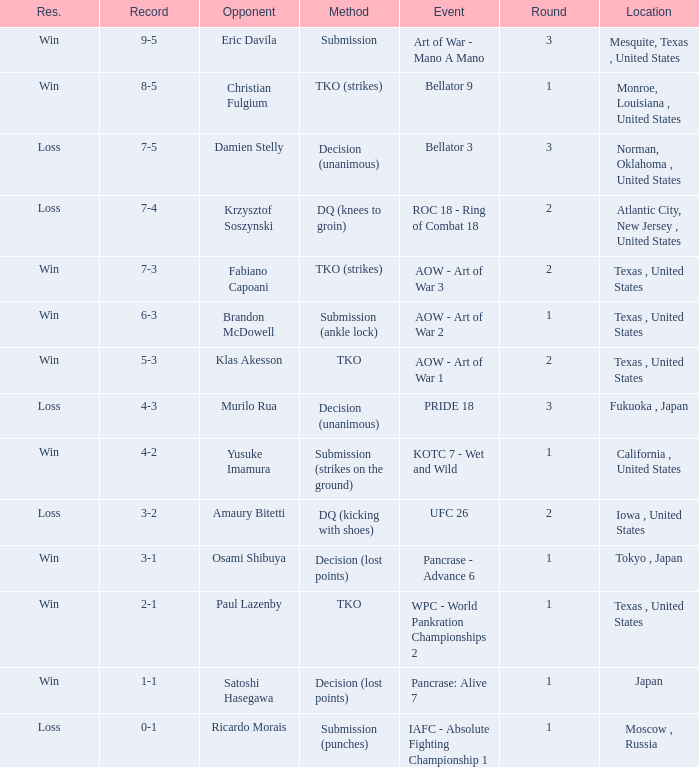When competing against klas akesson, what is the usual average round? 2.0. 